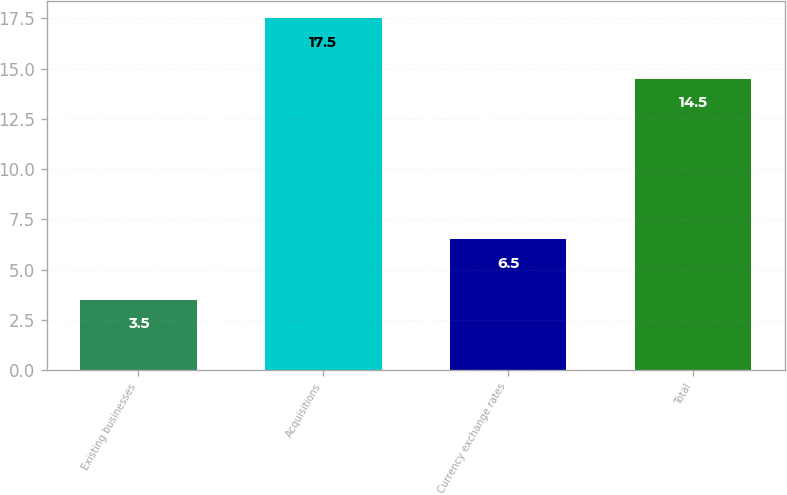Convert chart. <chart><loc_0><loc_0><loc_500><loc_500><bar_chart><fcel>Existing businesses<fcel>Acquisitions<fcel>Currency exchange rates<fcel>Total<nl><fcel>3.5<fcel>17.5<fcel>6.5<fcel>14.5<nl></chart> 